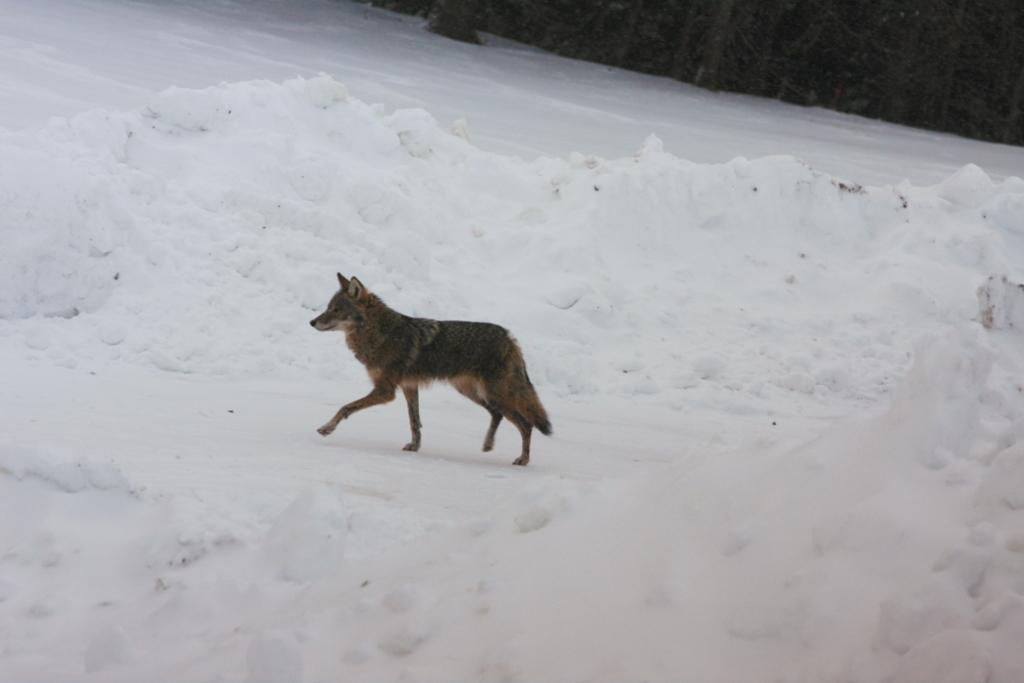What animal is present in the image? There is a wolf in the image. What is the wolf doing in the image? The wolf is walking on the ground in the image. What is the condition of the ground in the image? The ground has snow on it. What can be seen in the background of the image? There are trees in the background of the image. What type of plant is growing on the wolf's back in the image? There is no plant growing on the wolf's back in the image. What does the caption say about the wolf in the image? There is no caption present in the image. 